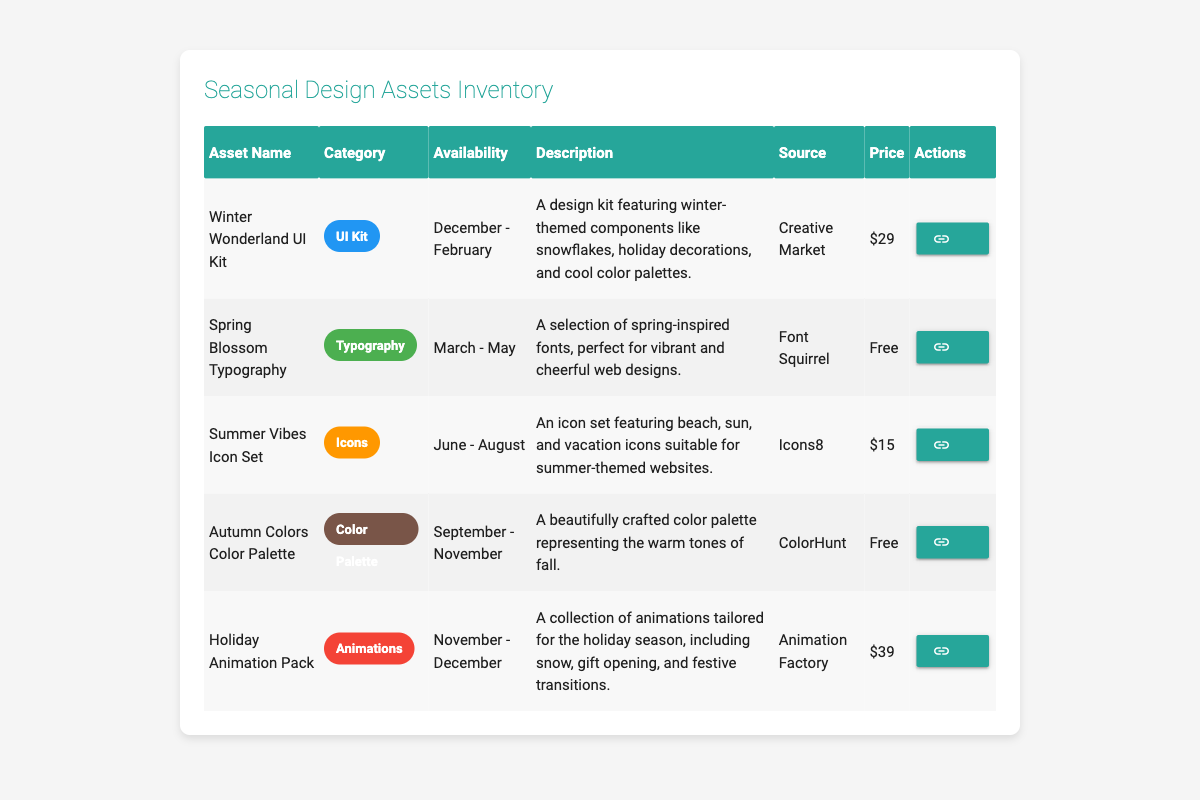What is the price of the Spring Blossom Typography asset? The Spring Blossom Typography asset is listed under the price column, which displays "Free."
Answer: Free Which category does the Holiday Animation Pack belong to? The Holiday Animation Pack is shown in the category column, where it is categorized as "Animations."
Answer: Animations During which months is the Summer Vibes Icon Set available? The availability column for the Summer Vibes Icon Set specifies "June - August."
Answer: June - August How many design assets are available for free in the inventory? There are two assets listed as free in the price column: Spring Blossom Typography and Autumn Colors Color Palette, making it a total of two assets.
Answer: 2 What is the price difference between the Winter Wonderland UI Kit and the Holiday Animation Pack? The Winter Wonderland UI Kit costs $29, and the Holiday Animation Pack costs $39. The price difference is $39 - $29 = $10.
Answer: $10 Is there any asset available for the month of November? The Holiday Animation Pack is listed with availability extending into December, and the Autumn Colors Color Palette is available from September - November, indicating that yes, there is an asset for November.
Answer: Yes Which source provides the Autumn Colors Color Palette? Looking at the source column in the row for the Autumn Colors Color Palette, it shows "ColorHunt."
Answer: ColorHunt Which asset has the highest price and what is that price? Upon examining the price column, the Holiday Animation Pack has the highest price at $39.
Answer: $39 How many categories feature assets that are available during the winter season? The Winter Wonderland UI Kit is the only asset available during December - February, categorized as a UI Kit, so it represents one category in this season.
Answer: 1 